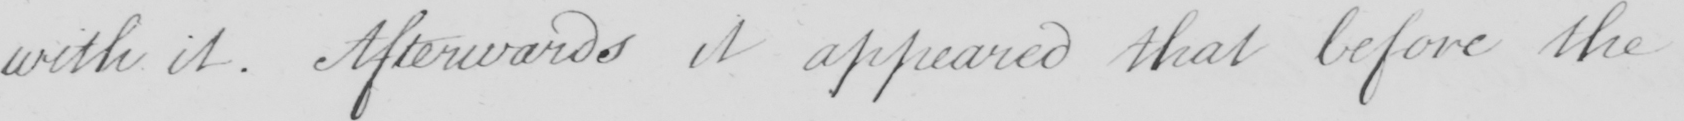Can you tell me what this handwritten text says? with it . Afterwards it appeared that before the 